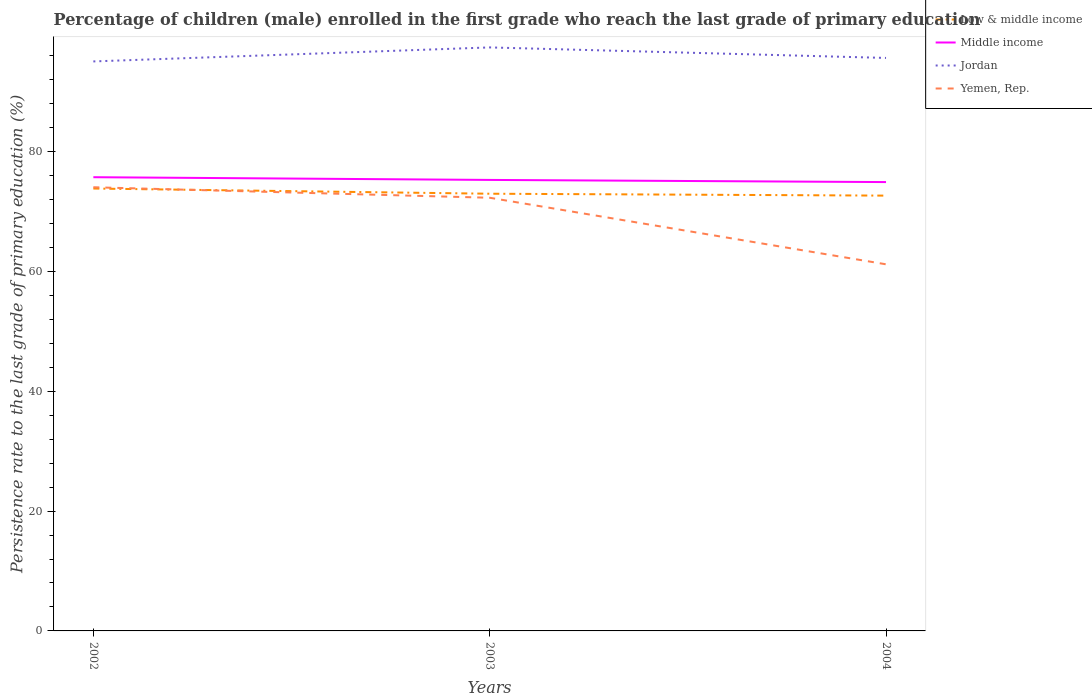Does the line corresponding to Jordan intersect with the line corresponding to Yemen, Rep.?
Make the answer very short. No. Is the number of lines equal to the number of legend labels?
Make the answer very short. Yes. Across all years, what is the maximum persistence rate of children in Yemen, Rep.?
Your response must be concise. 61.19. In which year was the persistence rate of children in Middle income maximum?
Provide a succinct answer. 2004. What is the total persistence rate of children in Jordan in the graph?
Your answer should be very brief. -0.58. What is the difference between the highest and the second highest persistence rate of children in Jordan?
Provide a succinct answer. 2.34. What is the difference between the highest and the lowest persistence rate of children in Yemen, Rep.?
Your answer should be compact. 2. Is the persistence rate of children in Jordan strictly greater than the persistence rate of children in Low & middle income over the years?
Ensure brevity in your answer.  No. How many years are there in the graph?
Ensure brevity in your answer.  3. What is the difference between two consecutive major ticks on the Y-axis?
Ensure brevity in your answer.  20. Are the values on the major ticks of Y-axis written in scientific E-notation?
Provide a succinct answer. No. Does the graph contain any zero values?
Give a very brief answer. No. Does the graph contain grids?
Keep it short and to the point. No. Where does the legend appear in the graph?
Give a very brief answer. Top right. What is the title of the graph?
Offer a very short reply. Percentage of children (male) enrolled in the first grade who reach the last grade of primary education. What is the label or title of the Y-axis?
Make the answer very short. Persistence rate to the last grade of primary education (%). What is the Persistence rate to the last grade of primary education (%) of Low & middle income in 2002?
Ensure brevity in your answer.  73.83. What is the Persistence rate to the last grade of primary education (%) of Middle income in 2002?
Keep it short and to the point. 75.73. What is the Persistence rate to the last grade of primary education (%) in Jordan in 2002?
Your answer should be very brief. 95.05. What is the Persistence rate to the last grade of primary education (%) of Yemen, Rep. in 2002?
Ensure brevity in your answer.  74.05. What is the Persistence rate to the last grade of primary education (%) in Low & middle income in 2003?
Provide a succinct answer. 72.97. What is the Persistence rate to the last grade of primary education (%) in Middle income in 2003?
Offer a very short reply. 75.27. What is the Persistence rate to the last grade of primary education (%) of Jordan in 2003?
Ensure brevity in your answer.  97.39. What is the Persistence rate to the last grade of primary education (%) in Yemen, Rep. in 2003?
Provide a short and direct response. 72.3. What is the Persistence rate to the last grade of primary education (%) of Low & middle income in 2004?
Give a very brief answer. 72.65. What is the Persistence rate to the last grade of primary education (%) of Middle income in 2004?
Your response must be concise. 74.91. What is the Persistence rate to the last grade of primary education (%) of Jordan in 2004?
Make the answer very short. 95.63. What is the Persistence rate to the last grade of primary education (%) in Yemen, Rep. in 2004?
Keep it short and to the point. 61.19. Across all years, what is the maximum Persistence rate to the last grade of primary education (%) of Low & middle income?
Your answer should be compact. 73.83. Across all years, what is the maximum Persistence rate to the last grade of primary education (%) of Middle income?
Give a very brief answer. 75.73. Across all years, what is the maximum Persistence rate to the last grade of primary education (%) in Jordan?
Keep it short and to the point. 97.39. Across all years, what is the maximum Persistence rate to the last grade of primary education (%) of Yemen, Rep.?
Your answer should be very brief. 74.05. Across all years, what is the minimum Persistence rate to the last grade of primary education (%) of Low & middle income?
Provide a short and direct response. 72.65. Across all years, what is the minimum Persistence rate to the last grade of primary education (%) in Middle income?
Give a very brief answer. 74.91. Across all years, what is the minimum Persistence rate to the last grade of primary education (%) of Jordan?
Provide a succinct answer. 95.05. Across all years, what is the minimum Persistence rate to the last grade of primary education (%) in Yemen, Rep.?
Your response must be concise. 61.19. What is the total Persistence rate to the last grade of primary education (%) of Low & middle income in the graph?
Keep it short and to the point. 219.46. What is the total Persistence rate to the last grade of primary education (%) in Middle income in the graph?
Make the answer very short. 225.91. What is the total Persistence rate to the last grade of primary education (%) in Jordan in the graph?
Your answer should be compact. 288.07. What is the total Persistence rate to the last grade of primary education (%) in Yemen, Rep. in the graph?
Your response must be concise. 207.54. What is the difference between the Persistence rate to the last grade of primary education (%) of Low & middle income in 2002 and that in 2003?
Offer a very short reply. 0.86. What is the difference between the Persistence rate to the last grade of primary education (%) in Middle income in 2002 and that in 2003?
Offer a very short reply. 0.45. What is the difference between the Persistence rate to the last grade of primary education (%) of Jordan in 2002 and that in 2003?
Give a very brief answer. -2.34. What is the difference between the Persistence rate to the last grade of primary education (%) of Yemen, Rep. in 2002 and that in 2003?
Your response must be concise. 1.75. What is the difference between the Persistence rate to the last grade of primary education (%) in Low & middle income in 2002 and that in 2004?
Your answer should be compact. 1.18. What is the difference between the Persistence rate to the last grade of primary education (%) of Middle income in 2002 and that in 2004?
Give a very brief answer. 0.81. What is the difference between the Persistence rate to the last grade of primary education (%) of Jordan in 2002 and that in 2004?
Your answer should be compact. -0.58. What is the difference between the Persistence rate to the last grade of primary education (%) of Yemen, Rep. in 2002 and that in 2004?
Your response must be concise. 12.86. What is the difference between the Persistence rate to the last grade of primary education (%) in Low & middle income in 2003 and that in 2004?
Your answer should be very brief. 0.32. What is the difference between the Persistence rate to the last grade of primary education (%) in Middle income in 2003 and that in 2004?
Your response must be concise. 0.36. What is the difference between the Persistence rate to the last grade of primary education (%) in Jordan in 2003 and that in 2004?
Ensure brevity in your answer.  1.76. What is the difference between the Persistence rate to the last grade of primary education (%) in Yemen, Rep. in 2003 and that in 2004?
Provide a short and direct response. 11.11. What is the difference between the Persistence rate to the last grade of primary education (%) in Low & middle income in 2002 and the Persistence rate to the last grade of primary education (%) in Middle income in 2003?
Your answer should be very brief. -1.44. What is the difference between the Persistence rate to the last grade of primary education (%) of Low & middle income in 2002 and the Persistence rate to the last grade of primary education (%) of Jordan in 2003?
Provide a short and direct response. -23.55. What is the difference between the Persistence rate to the last grade of primary education (%) in Low & middle income in 2002 and the Persistence rate to the last grade of primary education (%) in Yemen, Rep. in 2003?
Your answer should be very brief. 1.54. What is the difference between the Persistence rate to the last grade of primary education (%) in Middle income in 2002 and the Persistence rate to the last grade of primary education (%) in Jordan in 2003?
Keep it short and to the point. -21.66. What is the difference between the Persistence rate to the last grade of primary education (%) of Middle income in 2002 and the Persistence rate to the last grade of primary education (%) of Yemen, Rep. in 2003?
Provide a succinct answer. 3.43. What is the difference between the Persistence rate to the last grade of primary education (%) in Jordan in 2002 and the Persistence rate to the last grade of primary education (%) in Yemen, Rep. in 2003?
Give a very brief answer. 22.75. What is the difference between the Persistence rate to the last grade of primary education (%) of Low & middle income in 2002 and the Persistence rate to the last grade of primary education (%) of Middle income in 2004?
Provide a succinct answer. -1.08. What is the difference between the Persistence rate to the last grade of primary education (%) in Low & middle income in 2002 and the Persistence rate to the last grade of primary education (%) in Jordan in 2004?
Your answer should be compact. -21.8. What is the difference between the Persistence rate to the last grade of primary education (%) of Low & middle income in 2002 and the Persistence rate to the last grade of primary education (%) of Yemen, Rep. in 2004?
Your response must be concise. 12.65. What is the difference between the Persistence rate to the last grade of primary education (%) in Middle income in 2002 and the Persistence rate to the last grade of primary education (%) in Jordan in 2004?
Your answer should be very brief. -19.91. What is the difference between the Persistence rate to the last grade of primary education (%) of Middle income in 2002 and the Persistence rate to the last grade of primary education (%) of Yemen, Rep. in 2004?
Offer a very short reply. 14.54. What is the difference between the Persistence rate to the last grade of primary education (%) of Jordan in 2002 and the Persistence rate to the last grade of primary education (%) of Yemen, Rep. in 2004?
Your answer should be very brief. 33.86. What is the difference between the Persistence rate to the last grade of primary education (%) of Low & middle income in 2003 and the Persistence rate to the last grade of primary education (%) of Middle income in 2004?
Provide a short and direct response. -1.94. What is the difference between the Persistence rate to the last grade of primary education (%) of Low & middle income in 2003 and the Persistence rate to the last grade of primary education (%) of Jordan in 2004?
Offer a very short reply. -22.66. What is the difference between the Persistence rate to the last grade of primary education (%) of Low & middle income in 2003 and the Persistence rate to the last grade of primary education (%) of Yemen, Rep. in 2004?
Your answer should be very brief. 11.78. What is the difference between the Persistence rate to the last grade of primary education (%) in Middle income in 2003 and the Persistence rate to the last grade of primary education (%) in Jordan in 2004?
Give a very brief answer. -20.36. What is the difference between the Persistence rate to the last grade of primary education (%) of Middle income in 2003 and the Persistence rate to the last grade of primary education (%) of Yemen, Rep. in 2004?
Ensure brevity in your answer.  14.08. What is the difference between the Persistence rate to the last grade of primary education (%) of Jordan in 2003 and the Persistence rate to the last grade of primary education (%) of Yemen, Rep. in 2004?
Your answer should be very brief. 36.2. What is the average Persistence rate to the last grade of primary education (%) in Low & middle income per year?
Provide a succinct answer. 73.15. What is the average Persistence rate to the last grade of primary education (%) of Middle income per year?
Offer a terse response. 75.3. What is the average Persistence rate to the last grade of primary education (%) of Jordan per year?
Offer a terse response. 96.02. What is the average Persistence rate to the last grade of primary education (%) in Yemen, Rep. per year?
Your response must be concise. 69.18. In the year 2002, what is the difference between the Persistence rate to the last grade of primary education (%) in Low & middle income and Persistence rate to the last grade of primary education (%) in Middle income?
Your answer should be compact. -1.89. In the year 2002, what is the difference between the Persistence rate to the last grade of primary education (%) in Low & middle income and Persistence rate to the last grade of primary education (%) in Jordan?
Offer a terse response. -21.22. In the year 2002, what is the difference between the Persistence rate to the last grade of primary education (%) of Low & middle income and Persistence rate to the last grade of primary education (%) of Yemen, Rep.?
Offer a terse response. -0.21. In the year 2002, what is the difference between the Persistence rate to the last grade of primary education (%) in Middle income and Persistence rate to the last grade of primary education (%) in Jordan?
Offer a terse response. -19.32. In the year 2002, what is the difference between the Persistence rate to the last grade of primary education (%) of Middle income and Persistence rate to the last grade of primary education (%) of Yemen, Rep.?
Ensure brevity in your answer.  1.68. In the year 2002, what is the difference between the Persistence rate to the last grade of primary education (%) in Jordan and Persistence rate to the last grade of primary education (%) in Yemen, Rep.?
Ensure brevity in your answer.  21. In the year 2003, what is the difference between the Persistence rate to the last grade of primary education (%) of Low & middle income and Persistence rate to the last grade of primary education (%) of Middle income?
Offer a very short reply. -2.3. In the year 2003, what is the difference between the Persistence rate to the last grade of primary education (%) in Low & middle income and Persistence rate to the last grade of primary education (%) in Jordan?
Your answer should be compact. -24.42. In the year 2003, what is the difference between the Persistence rate to the last grade of primary education (%) in Low & middle income and Persistence rate to the last grade of primary education (%) in Yemen, Rep.?
Provide a short and direct response. 0.67. In the year 2003, what is the difference between the Persistence rate to the last grade of primary education (%) in Middle income and Persistence rate to the last grade of primary education (%) in Jordan?
Your answer should be compact. -22.11. In the year 2003, what is the difference between the Persistence rate to the last grade of primary education (%) in Middle income and Persistence rate to the last grade of primary education (%) in Yemen, Rep.?
Give a very brief answer. 2.98. In the year 2003, what is the difference between the Persistence rate to the last grade of primary education (%) in Jordan and Persistence rate to the last grade of primary education (%) in Yemen, Rep.?
Make the answer very short. 25.09. In the year 2004, what is the difference between the Persistence rate to the last grade of primary education (%) of Low & middle income and Persistence rate to the last grade of primary education (%) of Middle income?
Your response must be concise. -2.26. In the year 2004, what is the difference between the Persistence rate to the last grade of primary education (%) of Low & middle income and Persistence rate to the last grade of primary education (%) of Jordan?
Provide a short and direct response. -22.98. In the year 2004, what is the difference between the Persistence rate to the last grade of primary education (%) of Low & middle income and Persistence rate to the last grade of primary education (%) of Yemen, Rep.?
Give a very brief answer. 11.46. In the year 2004, what is the difference between the Persistence rate to the last grade of primary education (%) of Middle income and Persistence rate to the last grade of primary education (%) of Jordan?
Offer a very short reply. -20.72. In the year 2004, what is the difference between the Persistence rate to the last grade of primary education (%) in Middle income and Persistence rate to the last grade of primary education (%) in Yemen, Rep.?
Offer a very short reply. 13.72. In the year 2004, what is the difference between the Persistence rate to the last grade of primary education (%) in Jordan and Persistence rate to the last grade of primary education (%) in Yemen, Rep.?
Your answer should be compact. 34.44. What is the ratio of the Persistence rate to the last grade of primary education (%) in Low & middle income in 2002 to that in 2003?
Make the answer very short. 1.01. What is the ratio of the Persistence rate to the last grade of primary education (%) in Middle income in 2002 to that in 2003?
Your answer should be very brief. 1.01. What is the ratio of the Persistence rate to the last grade of primary education (%) in Yemen, Rep. in 2002 to that in 2003?
Provide a short and direct response. 1.02. What is the ratio of the Persistence rate to the last grade of primary education (%) of Low & middle income in 2002 to that in 2004?
Make the answer very short. 1.02. What is the ratio of the Persistence rate to the last grade of primary education (%) of Middle income in 2002 to that in 2004?
Your answer should be very brief. 1.01. What is the ratio of the Persistence rate to the last grade of primary education (%) of Yemen, Rep. in 2002 to that in 2004?
Provide a succinct answer. 1.21. What is the ratio of the Persistence rate to the last grade of primary education (%) in Low & middle income in 2003 to that in 2004?
Keep it short and to the point. 1. What is the ratio of the Persistence rate to the last grade of primary education (%) of Jordan in 2003 to that in 2004?
Your answer should be compact. 1.02. What is the ratio of the Persistence rate to the last grade of primary education (%) of Yemen, Rep. in 2003 to that in 2004?
Provide a short and direct response. 1.18. What is the difference between the highest and the second highest Persistence rate to the last grade of primary education (%) of Low & middle income?
Make the answer very short. 0.86. What is the difference between the highest and the second highest Persistence rate to the last grade of primary education (%) in Middle income?
Your response must be concise. 0.45. What is the difference between the highest and the second highest Persistence rate to the last grade of primary education (%) of Jordan?
Provide a succinct answer. 1.76. What is the difference between the highest and the second highest Persistence rate to the last grade of primary education (%) in Yemen, Rep.?
Ensure brevity in your answer.  1.75. What is the difference between the highest and the lowest Persistence rate to the last grade of primary education (%) of Low & middle income?
Your answer should be very brief. 1.18. What is the difference between the highest and the lowest Persistence rate to the last grade of primary education (%) of Middle income?
Make the answer very short. 0.81. What is the difference between the highest and the lowest Persistence rate to the last grade of primary education (%) of Jordan?
Ensure brevity in your answer.  2.34. What is the difference between the highest and the lowest Persistence rate to the last grade of primary education (%) of Yemen, Rep.?
Your answer should be compact. 12.86. 